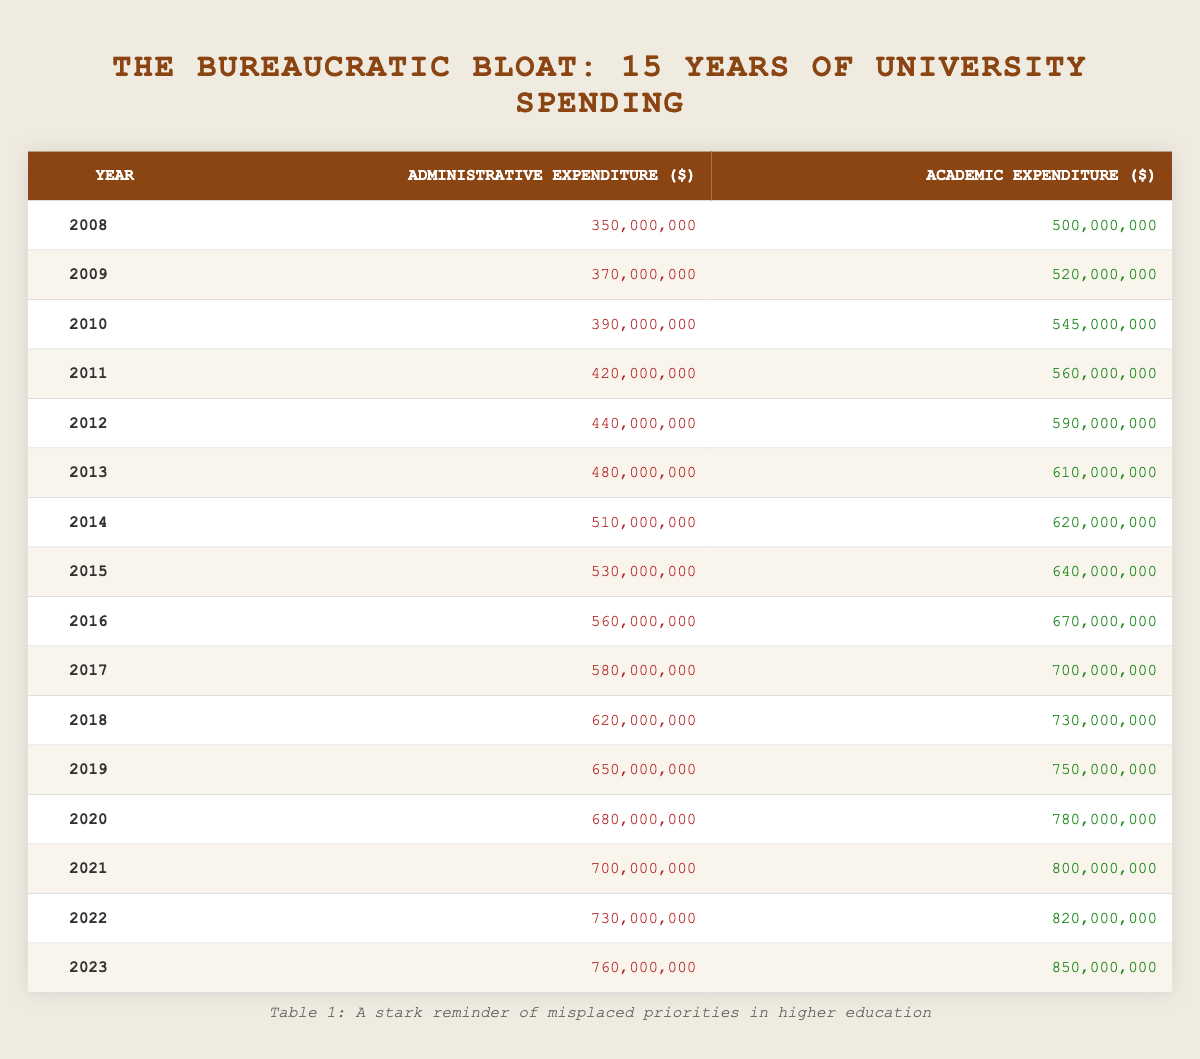What was the administrative expenditure in 2015? The table shows that in 2015, the administrative expenditure was 530,000,000 dollars.
Answer: 530,000,000 What is the academic expenditure for the year 2020? According to the table, the academic expenditure for 2020 is 780,000,000 dollars.
Answer: 780,000,000 Is the administrative expenditure higher than the academic expenditure in 2010? By checking the table, the administrative expenditure in 2010 is 390,000,000 dollars and the academic expenditure is 545,000,000 dollars. Since 390,000,000 is less than 545,000,000, the statement is false.
Answer: No What was the increase in administrative expenditure from 2008 to 2023? The administrative expenditure in 2008 was 350,000,000 dollars and in 2023 it was 760,000,000 dollars. To find the increase, subtract the earlier value from the later one: 760,000,000 - 350,000,000 = 410,000,000.
Answer: 410,000,000 What is the difference in academic expenditure between the years 2015 and 2022? The academic expenditure in 2015 was 640,000,000 dollars, and in 2022, it was 820,000,000 dollars. To find the difference, subtract 640,000,000 from 820,000,000: 820,000,000 - 640,000,000 = 180,000,000.
Answer: 180,000,000 Is it true that the sum of administrative expenditure from 2015 to 2020 exceeds 3 billion dollars? The administrative expenditures for the years in question are: 2015 (530,000,000), 2016 (560,000,000), 2017 (580,000,000), 2018 (620,000,000), 2019 (650,000,000), and 2020 (680,000,000). Adding these gives: 530,000,000 + 560,000,000 + 580,000,000 + 620,000,000 + 650,000,000 + 680,000,000 = 3,620,000,000, which exceeds 3 billion. Thus, the statement is true.
Answer: Yes What is the average academic expenditure over the entire period? To find the average: First, sum the academic expenditures from each year: 500,000,000 + 520,000,000 + 545,000,000 + 560,000,000 + 590,000,000 + 610,000,000 + 620,000,000 + 640,000,000 + 670,000,000 + 700,000,000 + 730,000,000 + 750,000,000 + 780,000,000 + 800,000,000 + 820,000,000 + 850,000,000 = 10,330,000,000. There are 16 years, so divide by 16: 10,330,000,000 / 16 = 645,625,000.
Answer: 645,625,000 In which year did the administrative expenditure first exceed 600 million dollars? By examining the table, the administrative expenditure exceeds 600 million dollars in the year 2018 (620,000,000), while in 2017 it was still 580,000,000. Thus, the first occurrence is in 2018.
Answer: 2018 